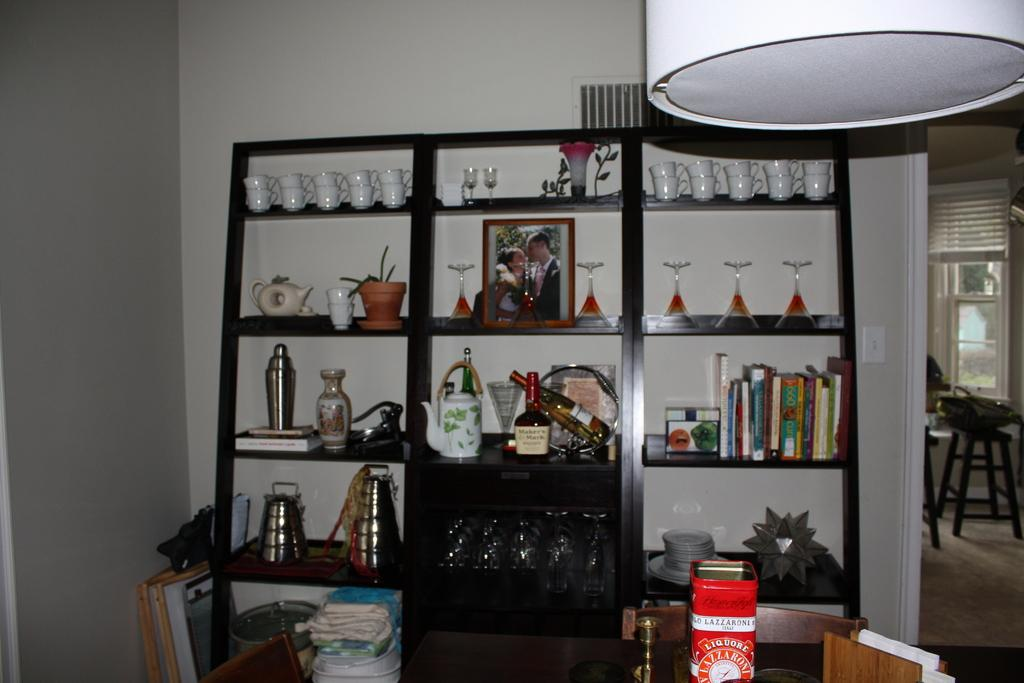What can be seen on the racks in the image? There are objects on the racks in the image. What type of furniture is present in the image? There are sitting chairs and tables in the image. What is the feature on the right side of the image? There is a glass window on the right side of the image. Are there any crooks in the image? There is no mention of any crooks in the image, so we cannot confirm their presence. What type of pets can be seen in the image? There is no mention of any pets in the image, so we cannot confirm their presence. 